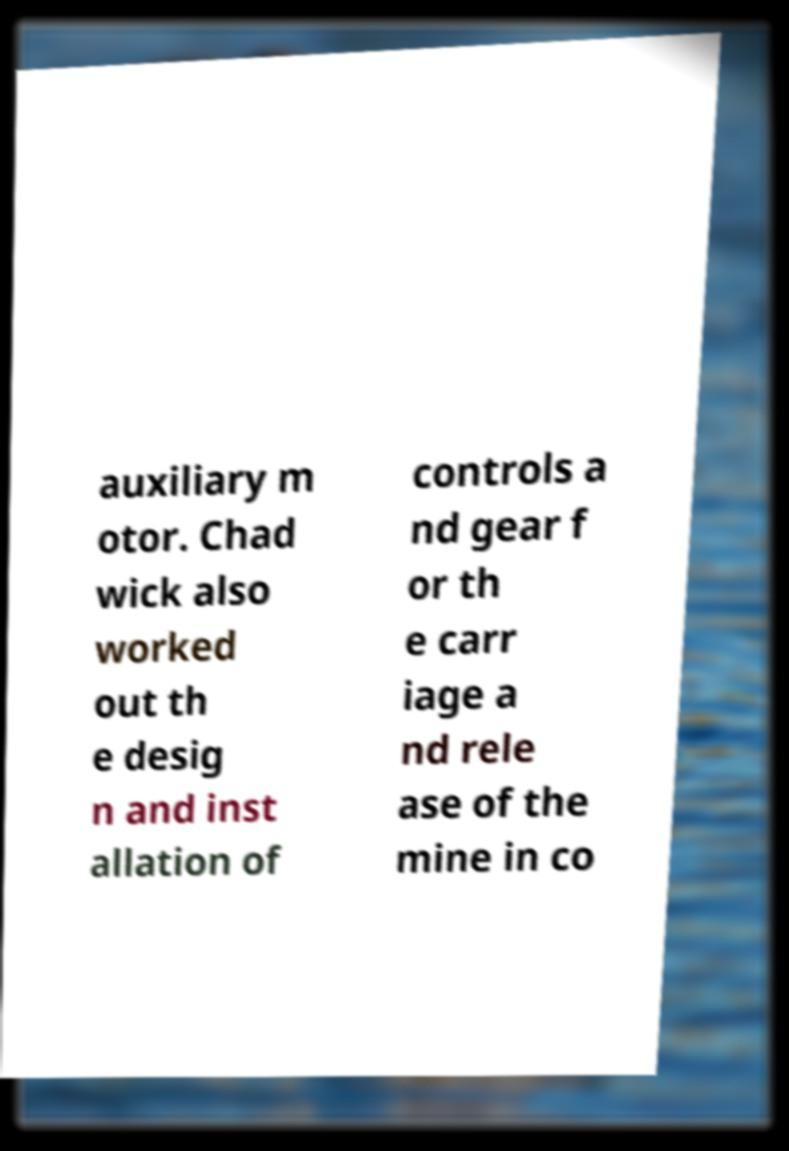What messages or text are displayed in this image? I need them in a readable, typed format. auxiliary m otor. Chad wick also worked out th e desig n and inst allation of controls a nd gear f or th e carr iage a nd rele ase of the mine in co 